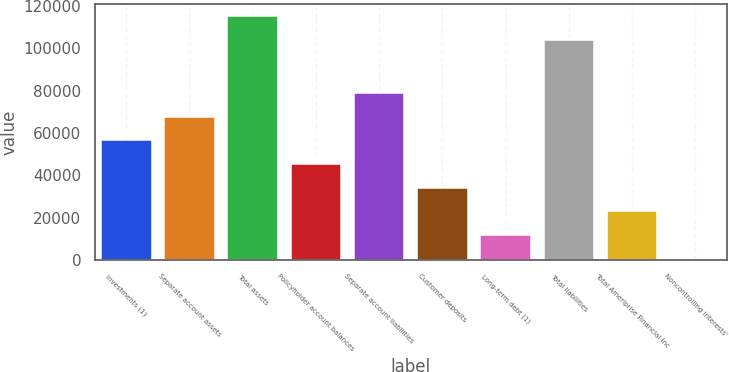Convert chart to OTSL. <chart><loc_0><loc_0><loc_500><loc_500><bar_chart><fcel>Investments (1)<fcel>Separate account assets<fcel>Total assets<fcel>Policyholder account balances<fcel>Separate account liabilities<fcel>Customer deposits<fcel>Long-term debt (1)<fcel>Total liabilities<fcel>Total Ameriprise Financial Inc<fcel>Noncontrolling interests'<nl><fcel>56565.5<fcel>67758<fcel>115120<fcel>45373<fcel>78950.5<fcel>34180.5<fcel>11795.5<fcel>103928<fcel>22988<fcel>603<nl></chart> 